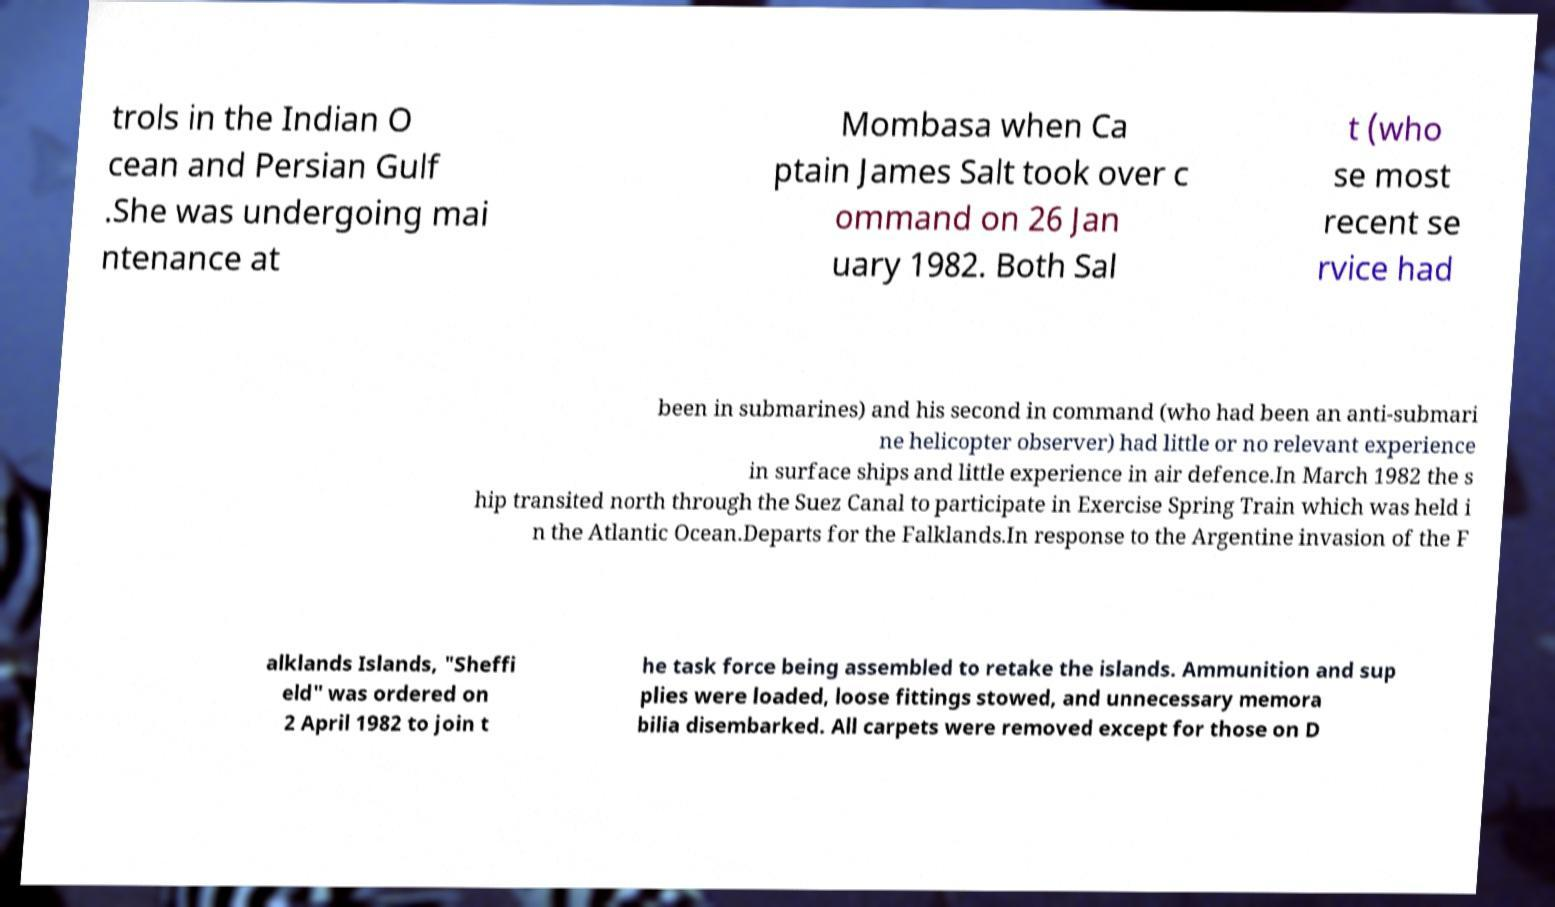Can you accurately transcribe the text from the provided image for me? trols in the Indian O cean and Persian Gulf .She was undergoing mai ntenance at Mombasa when Ca ptain James Salt took over c ommand on 26 Jan uary 1982. Both Sal t (who se most recent se rvice had been in submarines) and his second in command (who had been an anti-submari ne helicopter observer) had little or no relevant experience in surface ships and little experience in air defence.In March 1982 the s hip transited north through the Suez Canal to participate in Exercise Spring Train which was held i n the Atlantic Ocean.Departs for the Falklands.In response to the Argentine invasion of the F alklands Islands, "Sheffi eld" was ordered on 2 April 1982 to join t he task force being assembled to retake the islands. Ammunition and sup plies were loaded, loose fittings stowed, and unnecessary memora bilia disembarked. All carpets were removed except for those on D 